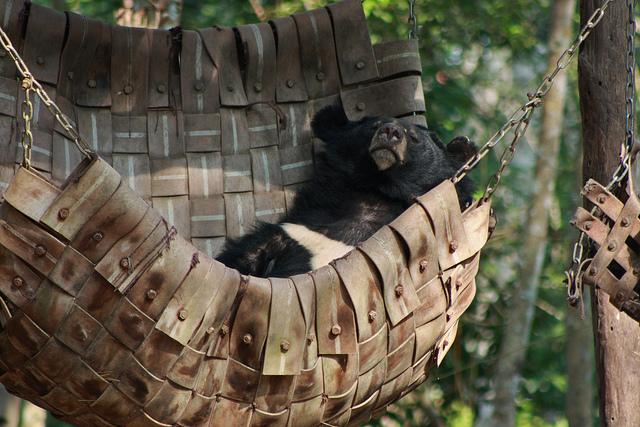Is the bear sleeping?
Answer briefly. Yes. What is the bear lying in?
Be succinct. Hammock. Is this a wild bear?
Answer briefly. No. 